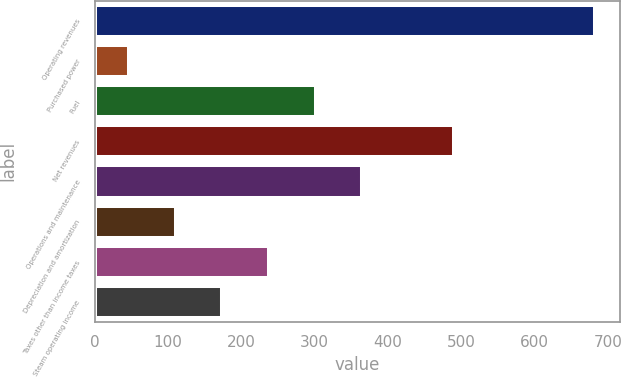<chart> <loc_0><loc_0><loc_500><loc_500><bar_chart><fcel>Operating revenues<fcel>Purchased power<fcel>Fuel<fcel>Net revenues<fcel>Operations and maintenance<fcel>Depreciation and amortization<fcel>Taxes other than income taxes<fcel>Steam operating income<nl><fcel>683<fcel>47<fcel>301.4<fcel>490<fcel>365<fcel>110.6<fcel>237.8<fcel>174.2<nl></chart> 